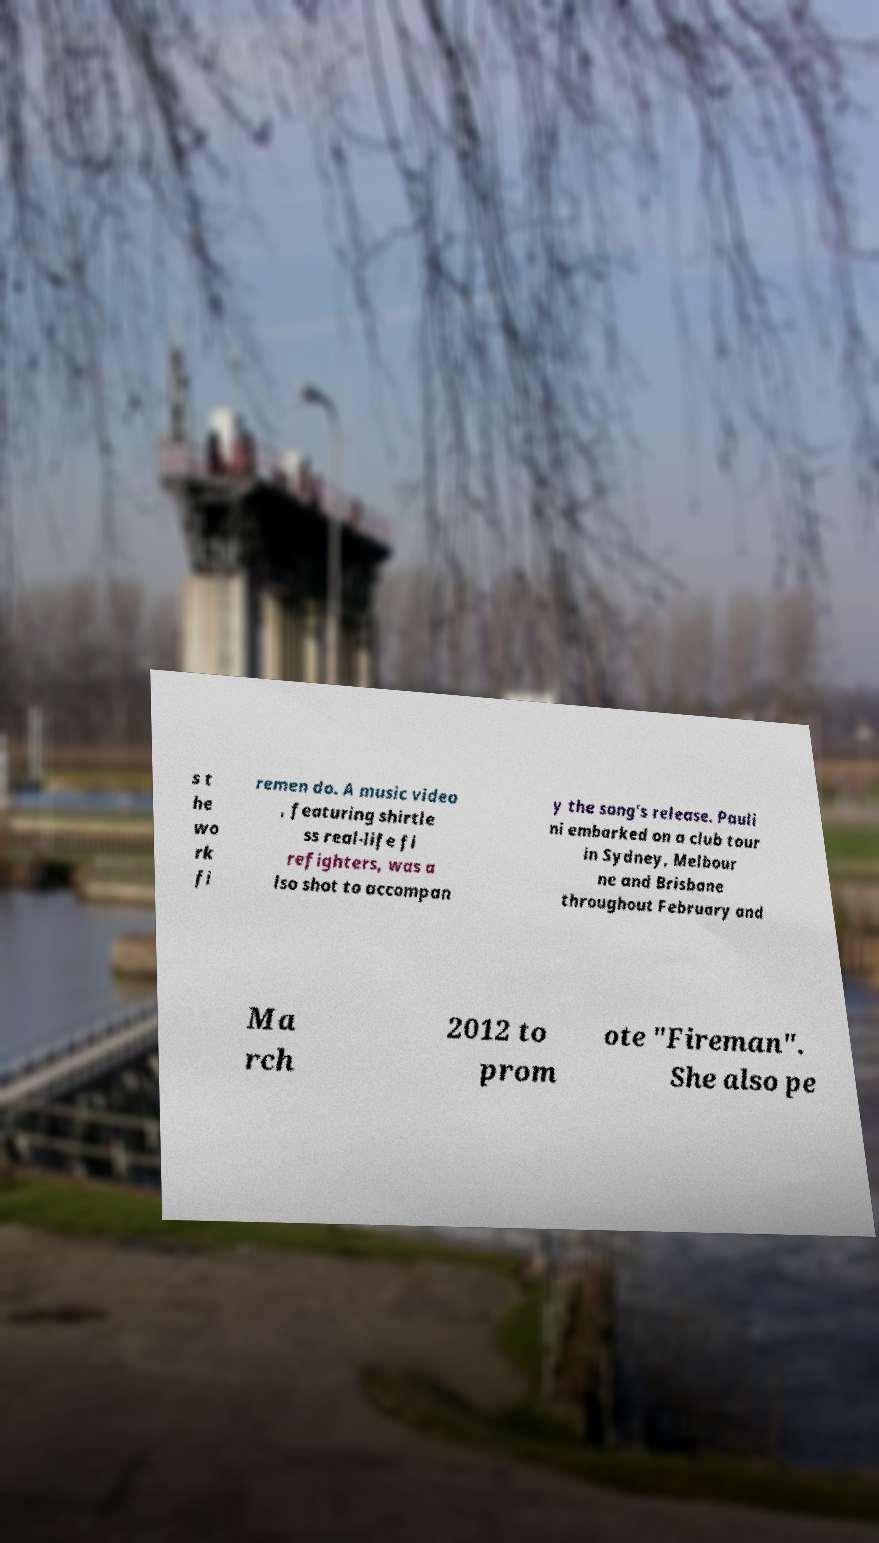I need the written content from this picture converted into text. Can you do that? s t he wo rk fi remen do. A music video , featuring shirtle ss real-life fi refighters, was a lso shot to accompan y the song's release. Pauli ni embarked on a club tour in Sydney, Melbour ne and Brisbane throughout February and Ma rch 2012 to prom ote "Fireman". She also pe 